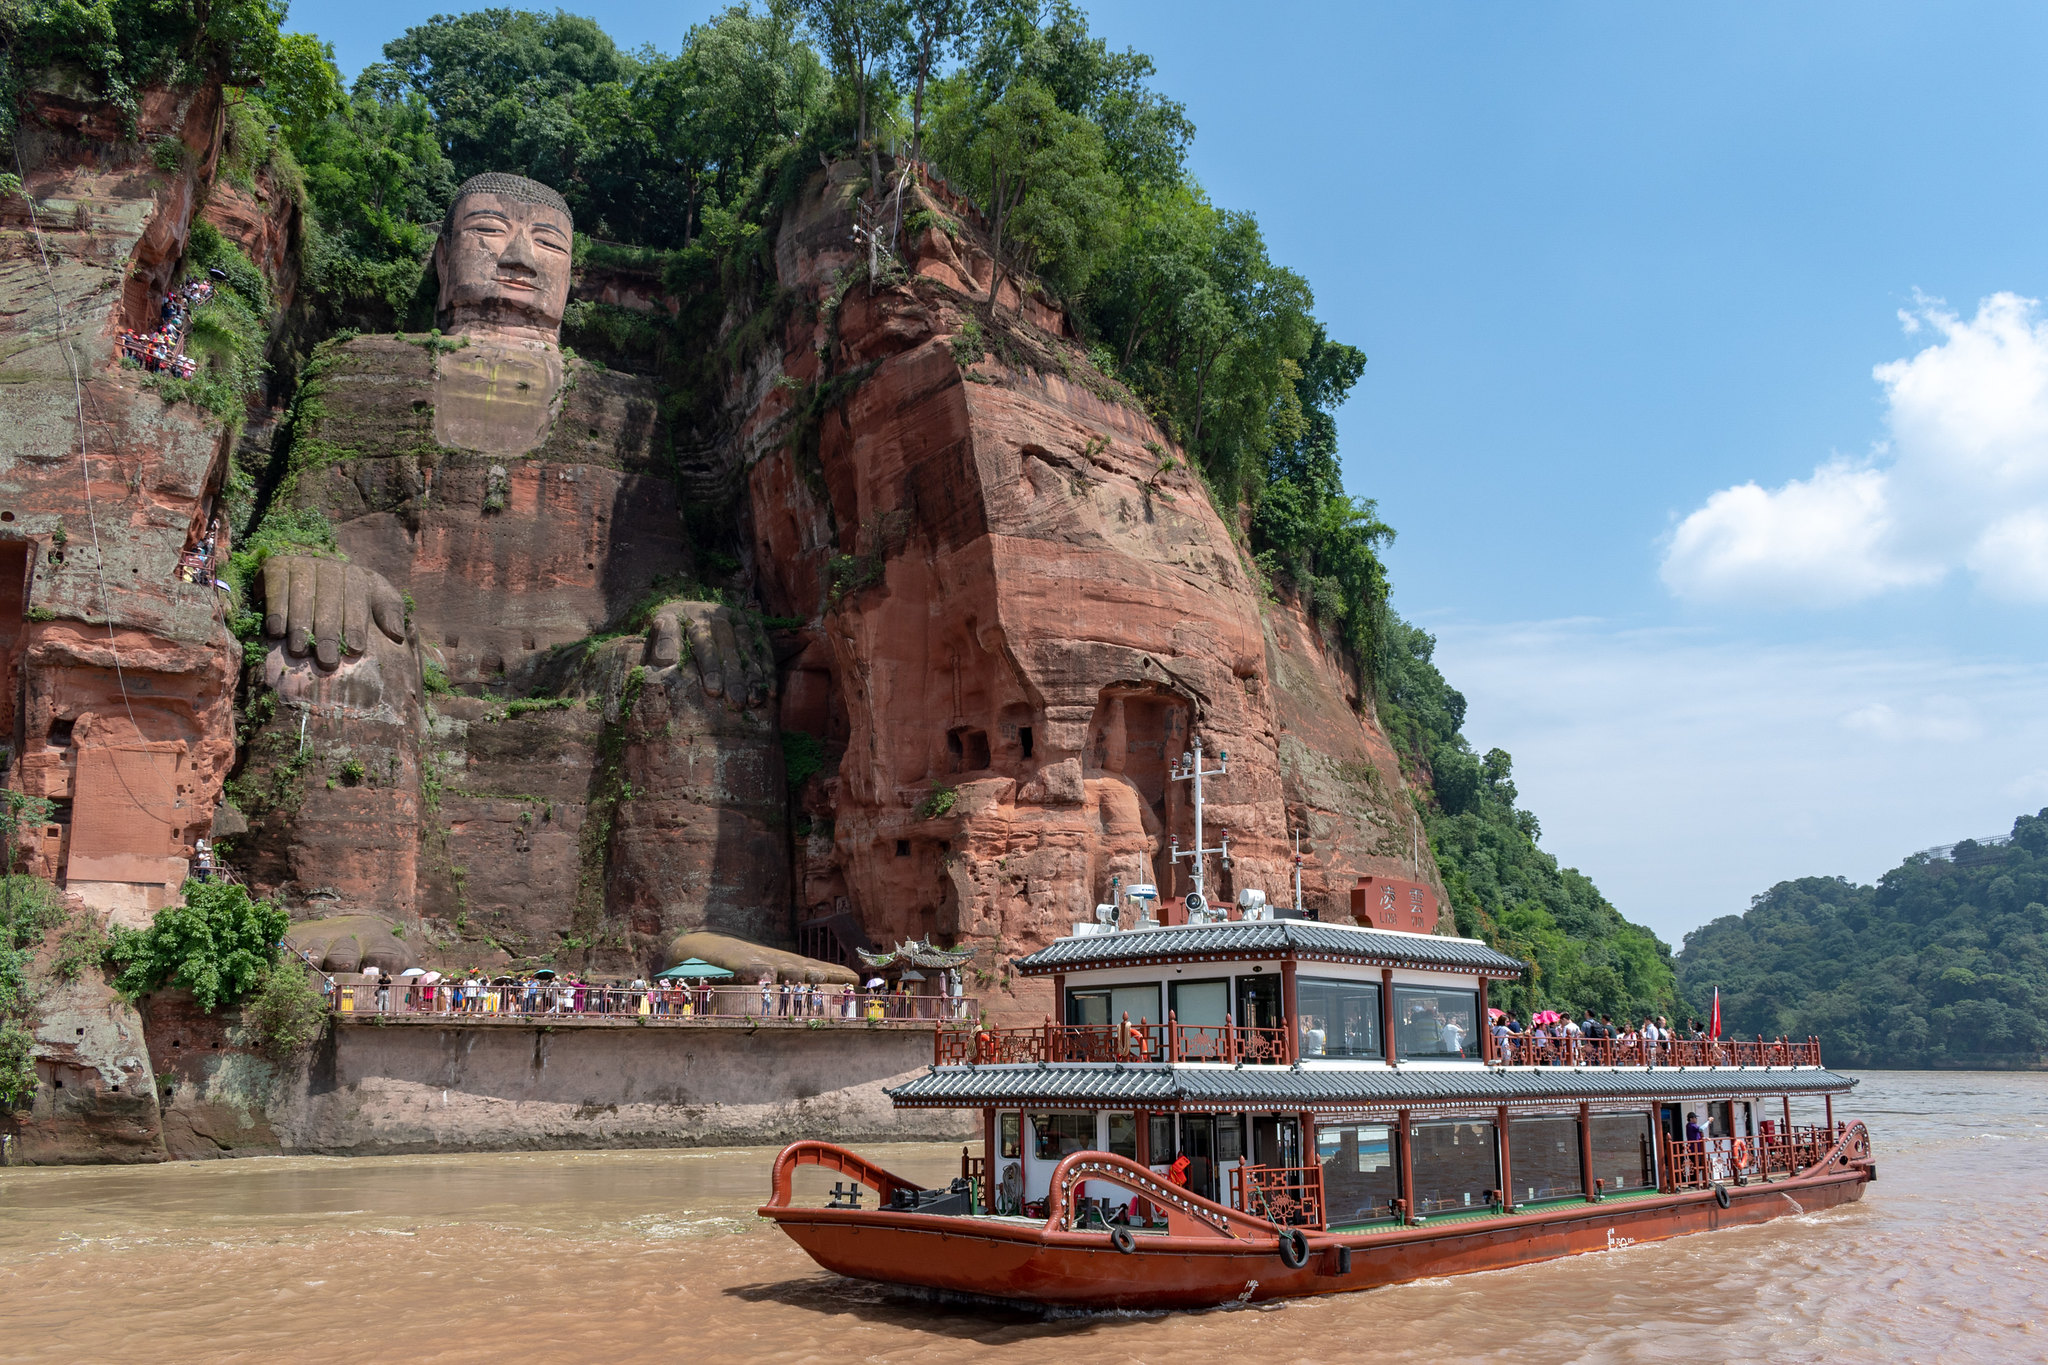Could you describe the historical significance of this site? The Leshan Giant Buddha, built between 713 and 803 AD during the Tang Dynasty, holds immense historical significance. It was constructed by a monk named Haitong, who aimed to calm the turbulent waters that plagued the shipping vessels traveling down the river. Remarkably, it took more than 90 years to complete the statue, which now stands as a testament to ancient Chinese engineering and artistry. Over the centuries, this site has been a place of cultural and religious importance and continues to attract visitors from around the world, marveling at its storied past and spiritual significance. 